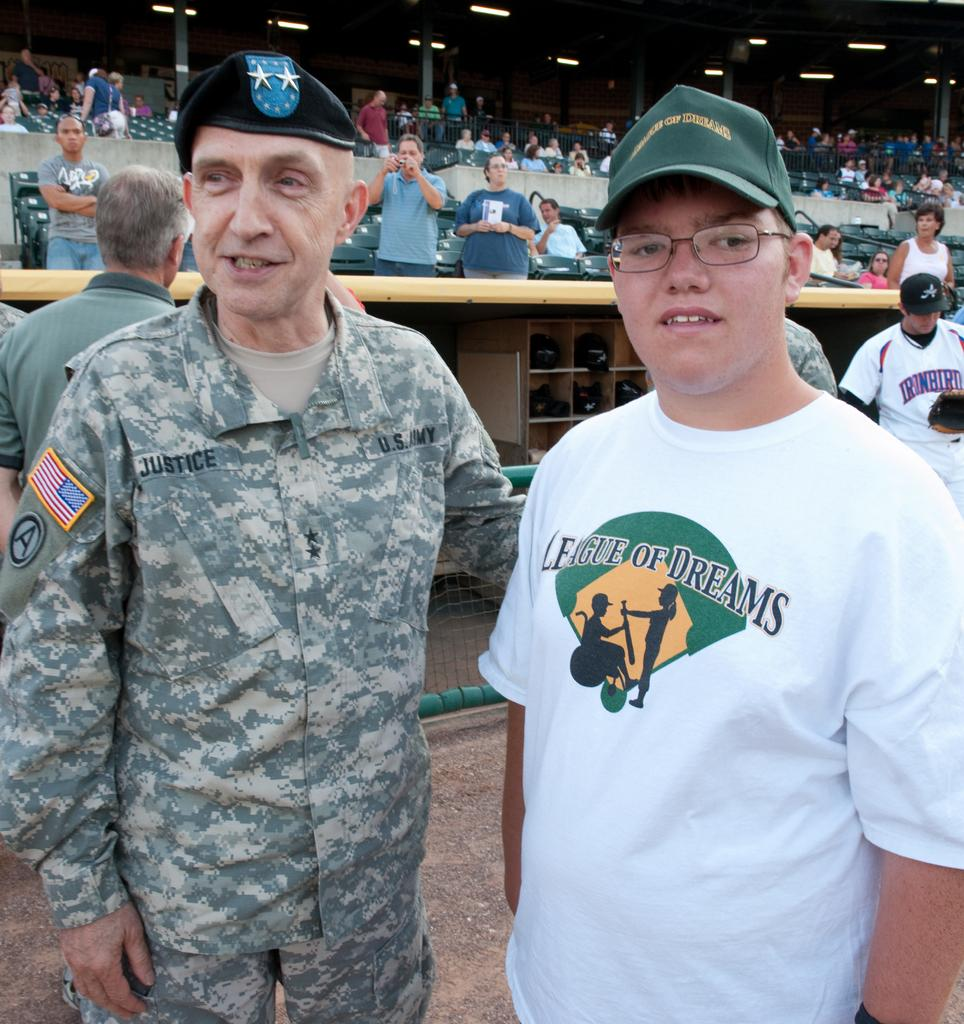<image>
Provide a brief description of the given image. Army soldier Justice standing with a boy wearing a League of Dreams tshirt. 